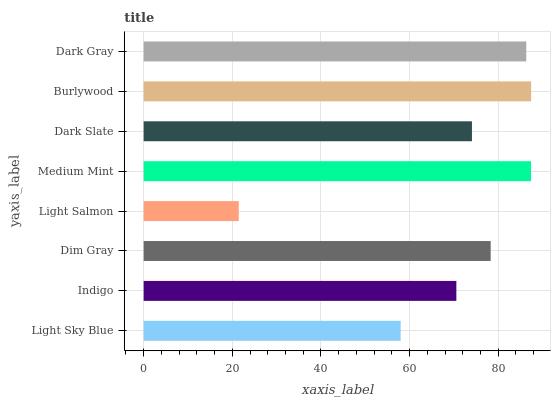Is Light Salmon the minimum?
Answer yes or no. Yes. Is Burlywood the maximum?
Answer yes or no. Yes. Is Indigo the minimum?
Answer yes or no. No. Is Indigo the maximum?
Answer yes or no. No. Is Indigo greater than Light Sky Blue?
Answer yes or no. Yes. Is Light Sky Blue less than Indigo?
Answer yes or no. Yes. Is Light Sky Blue greater than Indigo?
Answer yes or no. No. Is Indigo less than Light Sky Blue?
Answer yes or no. No. Is Dim Gray the high median?
Answer yes or no. Yes. Is Dark Slate the low median?
Answer yes or no. Yes. Is Light Sky Blue the high median?
Answer yes or no. No. Is Dark Gray the low median?
Answer yes or no. No. 